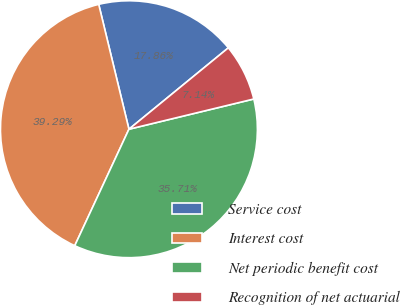<chart> <loc_0><loc_0><loc_500><loc_500><pie_chart><fcel>Service cost<fcel>Interest cost<fcel>Net periodic benefit cost<fcel>Recognition of net actuarial<nl><fcel>17.86%<fcel>39.29%<fcel>35.71%<fcel>7.14%<nl></chart> 